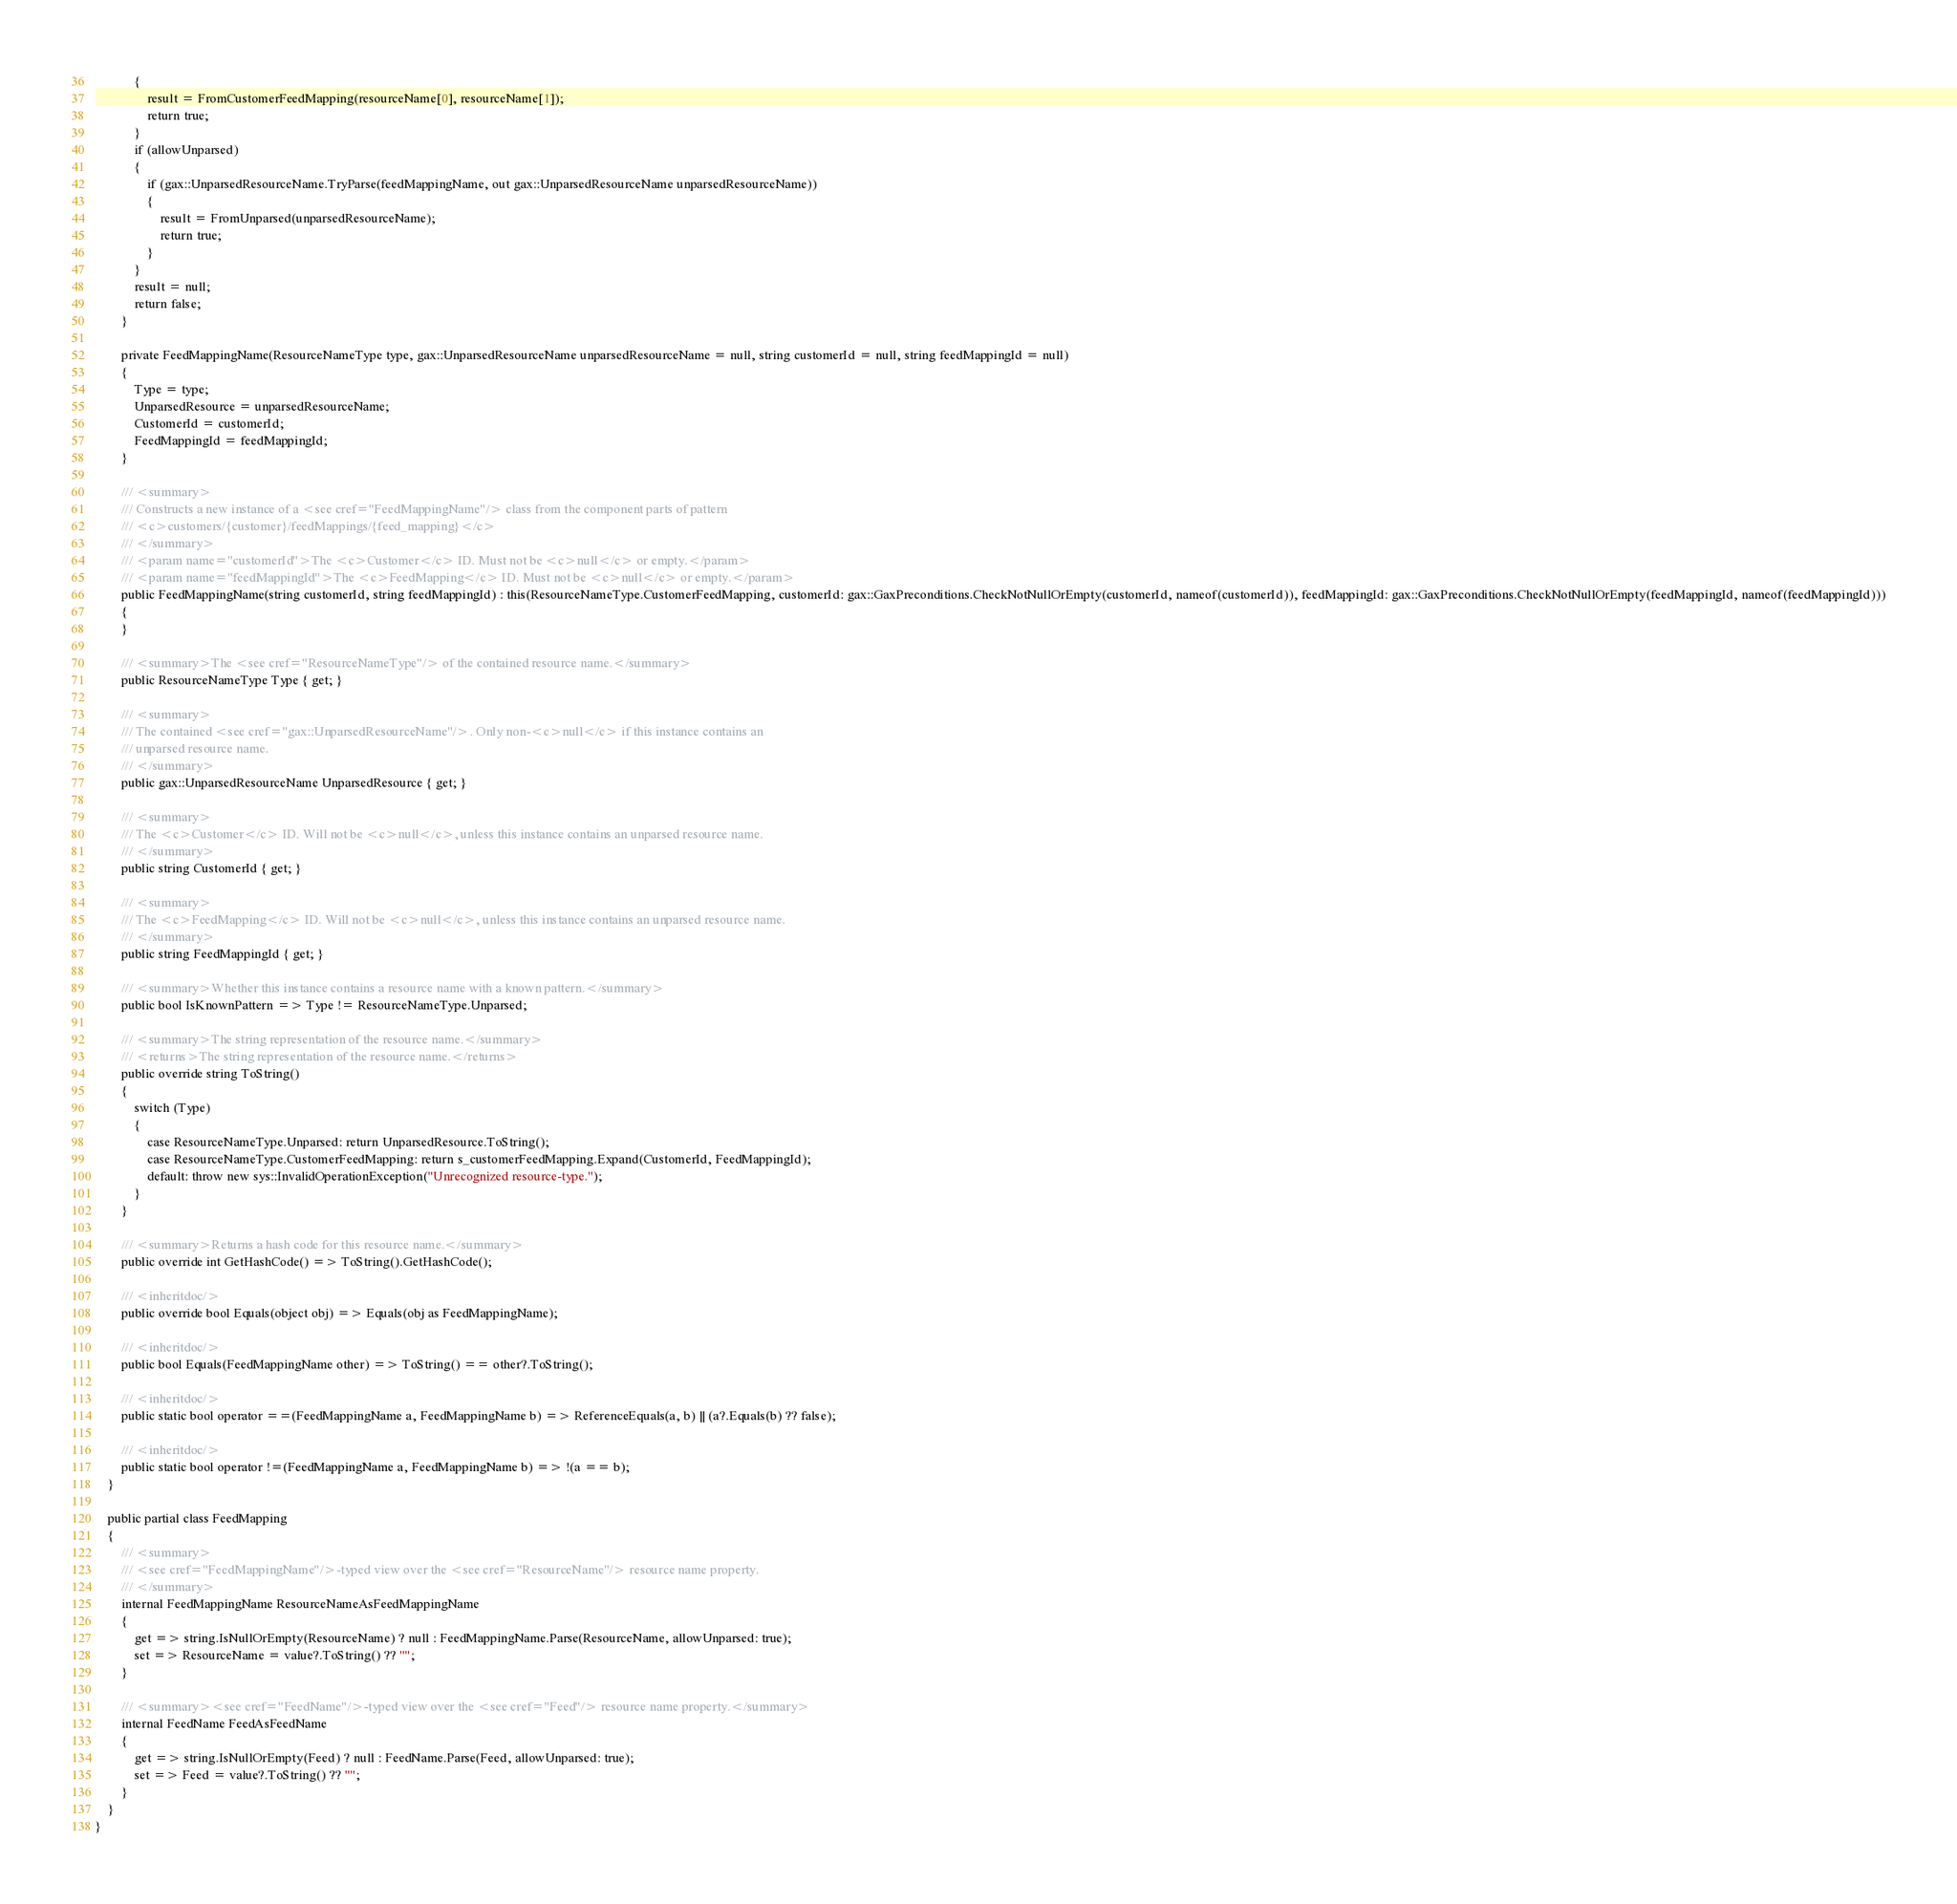<code> <loc_0><loc_0><loc_500><loc_500><_C#_>            {
                result = FromCustomerFeedMapping(resourceName[0], resourceName[1]);
                return true;
            }
            if (allowUnparsed)
            {
                if (gax::UnparsedResourceName.TryParse(feedMappingName, out gax::UnparsedResourceName unparsedResourceName))
                {
                    result = FromUnparsed(unparsedResourceName);
                    return true;
                }
            }
            result = null;
            return false;
        }

        private FeedMappingName(ResourceNameType type, gax::UnparsedResourceName unparsedResourceName = null, string customerId = null, string feedMappingId = null)
        {
            Type = type;
            UnparsedResource = unparsedResourceName;
            CustomerId = customerId;
            FeedMappingId = feedMappingId;
        }

        /// <summary>
        /// Constructs a new instance of a <see cref="FeedMappingName"/> class from the component parts of pattern
        /// <c>customers/{customer}/feedMappings/{feed_mapping}</c>
        /// </summary>
        /// <param name="customerId">The <c>Customer</c> ID. Must not be <c>null</c> or empty.</param>
        /// <param name="feedMappingId">The <c>FeedMapping</c> ID. Must not be <c>null</c> or empty.</param>
        public FeedMappingName(string customerId, string feedMappingId) : this(ResourceNameType.CustomerFeedMapping, customerId: gax::GaxPreconditions.CheckNotNullOrEmpty(customerId, nameof(customerId)), feedMappingId: gax::GaxPreconditions.CheckNotNullOrEmpty(feedMappingId, nameof(feedMappingId)))
        {
        }

        /// <summary>The <see cref="ResourceNameType"/> of the contained resource name.</summary>
        public ResourceNameType Type { get; }

        /// <summary>
        /// The contained <see cref="gax::UnparsedResourceName"/>. Only non-<c>null</c> if this instance contains an
        /// unparsed resource name.
        /// </summary>
        public gax::UnparsedResourceName UnparsedResource { get; }

        /// <summary>
        /// The <c>Customer</c> ID. Will not be <c>null</c>, unless this instance contains an unparsed resource name.
        /// </summary>
        public string CustomerId { get; }

        /// <summary>
        /// The <c>FeedMapping</c> ID. Will not be <c>null</c>, unless this instance contains an unparsed resource name.
        /// </summary>
        public string FeedMappingId { get; }

        /// <summary>Whether this instance contains a resource name with a known pattern.</summary>
        public bool IsKnownPattern => Type != ResourceNameType.Unparsed;

        /// <summary>The string representation of the resource name.</summary>
        /// <returns>The string representation of the resource name.</returns>
        public override string ToString()
        {
            switch (Type)
            {
                case ResourceNameType.Unparsed: return UnparsedResource.ToString();
                case ResourceNameType.CustomerFeedMapping: return s_customerFeedMapping.Expand(CustomerId, FeedMappingId);
                default: throw new sys::InvalidOperationException("Unrecognized resource-type.");
            }
        }

        /// <summary>Returns a hash code for this resource name.</summary>
        public override int GetHashCode() => ToString().GetHashCode();

        /// <inheritdoc/>
        public override bool Equals(object obj) => Equals(obj as FeedMappingName);

        /// <inheritdoc/>
        public bool Equals(FeedMappingName other) => ToString() == other?.ToString();

        /// <inheritdoc/>
        public static bool operator ==(FeedMappingName a, FeedMappingName b) => ReferenceEquals(a, b) || (a?.Equals(b) ?? false);

        /// <inheritdoc/>
        public static bool operator !=(FeedMappingName a, FeedMappingName b) => !(a == b);
    }

    public partial class FeedMapping
    {
        /// <summary>
        /// <see cref="FeedMappingName"/>-typed view over the <see cref="ResourceName"/> resource name property.
        /// </summary>
        internal FeedMappingName ResourceNameAsFeedMappingName
        {
            get => string.IsNullOrEmpty(ResourceName) ? null : FeedMappingName.Parse(ResourceName, allowUnparsed: true);
            set => ResourceName = value?.ToString() ?? "";
        }

        /// <summary><see cref="FeedName"/>-typed view over the <see cref="Feed"/> resource name property.</summary>
        internal FeedName FeedAsFeedName
        {
            get => string.IsNullOrEmpty(Feed) ? null : FeedName.Parse(Feed, allowUnparsed: true);
            set => Feed = value?.ToString() ?? "";
        }
    }
}
</code> 